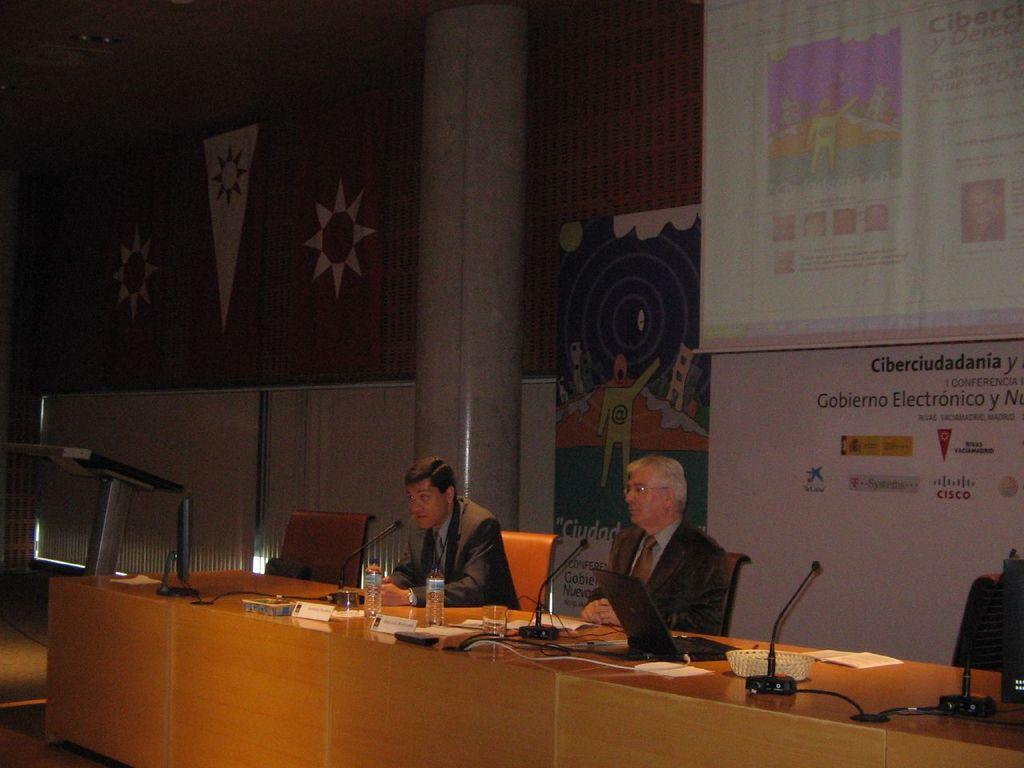Could you give a brief overview of what you see in this image? In the foreground of the picture we can see tables, mics, papers, name plates, water bottle, water bottles, people, chairs and various objects. In the background there are banners, pillar, wall, window blinds and other objects. 